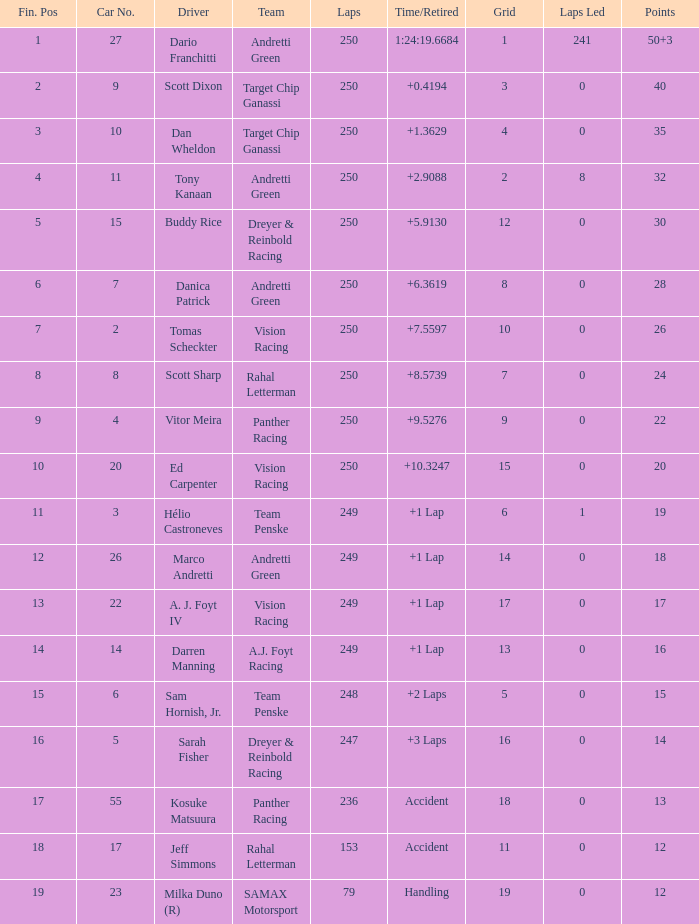Name the total number of cars for panther racing and grid of 9 1.0. 